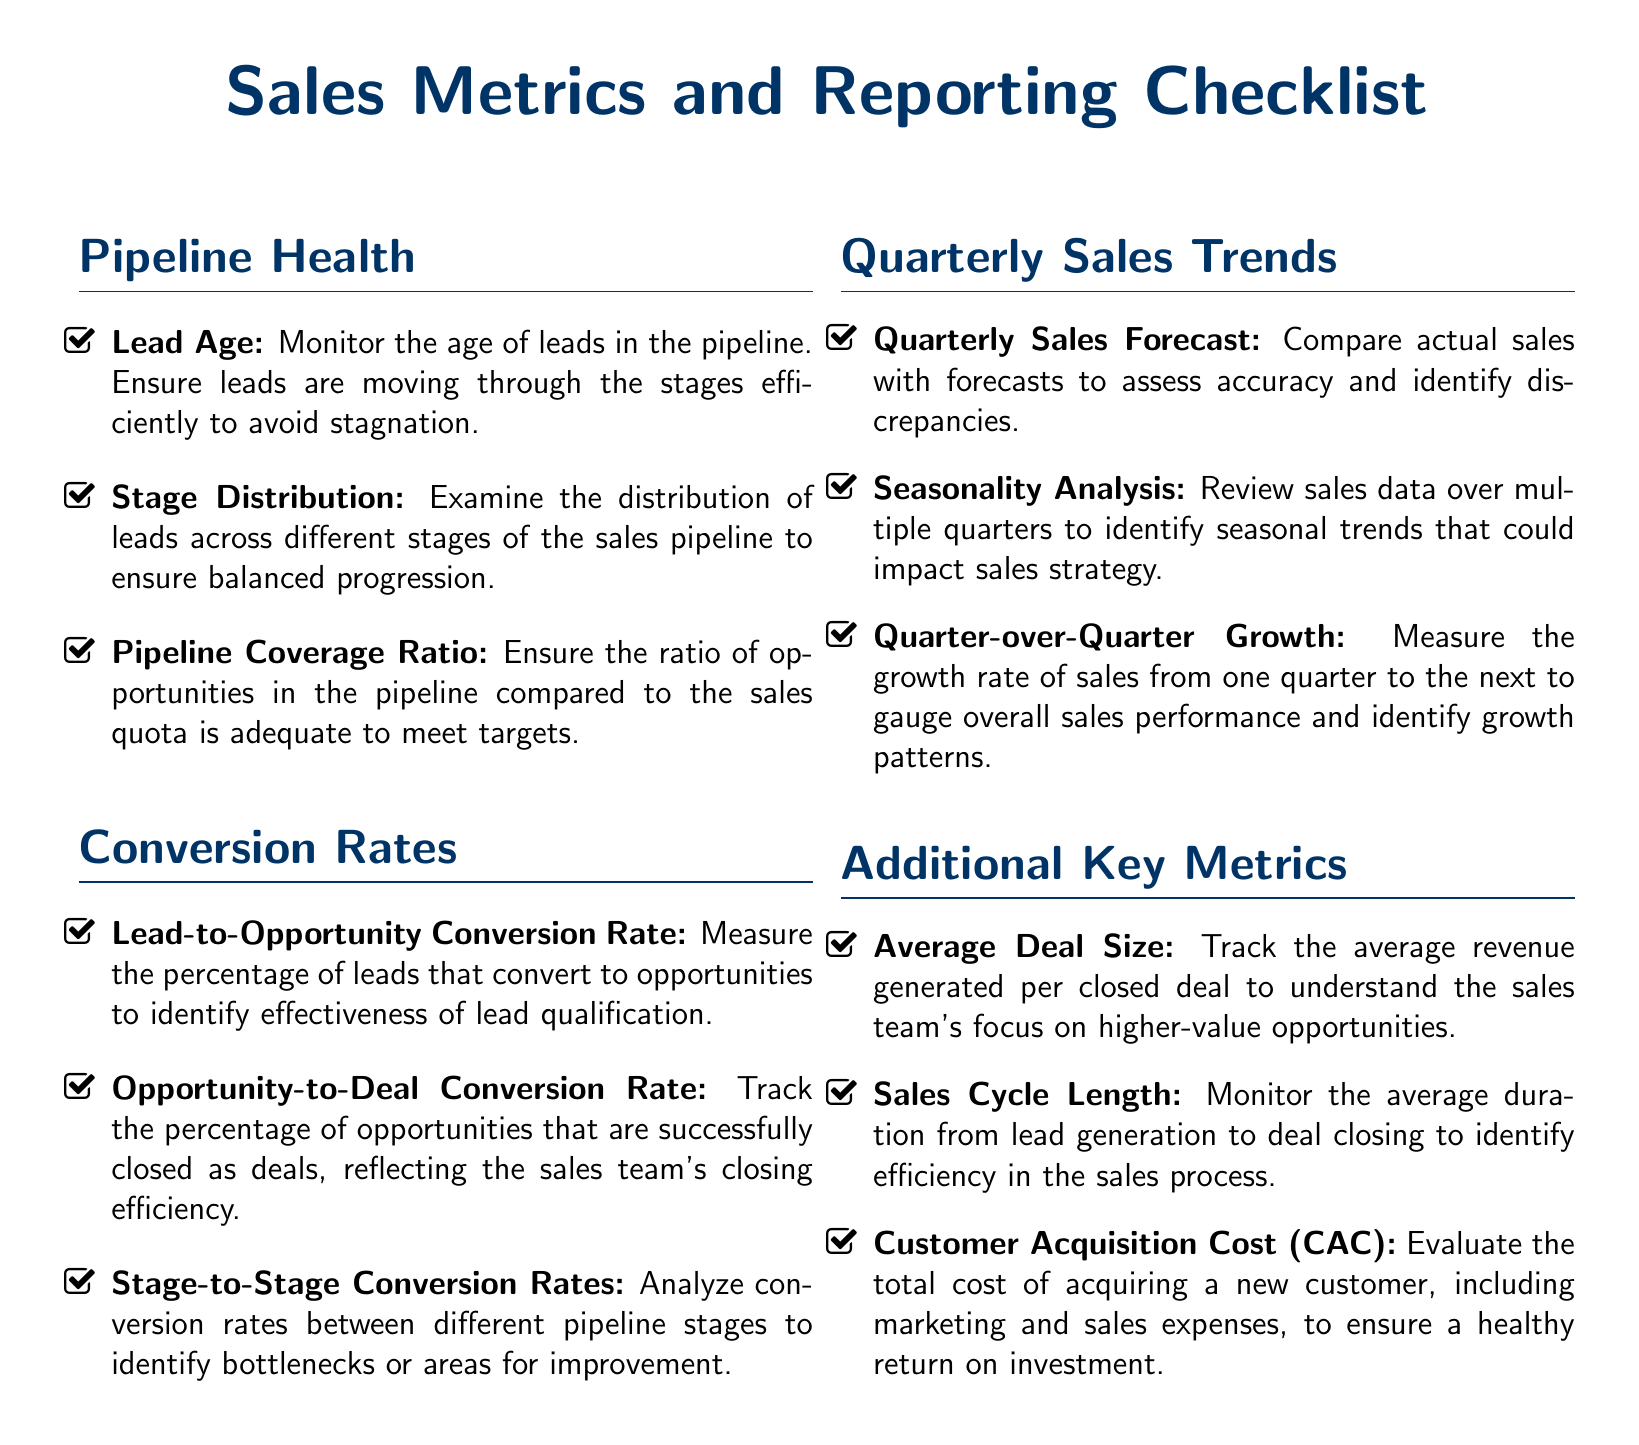What is monitored to ensure leads are moving efficiently? The document specifies that lead age should be monitored to ensure leads are moving through the stages efficiently.
Answer: Lead Age Which metric analyzes conversion rates between different pipeline stages? The document states that stage-to-stage conversion rates should be analyzed to identify bottlenecks or areas for improvement.
Answer: Stage-to-Stage Conversion Rates What should be compared to assess forecast accuracy? The document mentions comparing actual sales with forecasts to assess accuracy.
Answer: Quarterly Sales Forecast What metric evaluates the total cost of acquiring a new customer? The document states that customer acquisition cost (CAC) evaluates the total cost of acquiring a new customer.
Answer: Customer Acquisition Cost (CAC) How is the efficiency of the sales process monitored? The document indicates that the average duration from lead generation to deal closing is monitored to identify efficiency.
Answer: Sales Cycle Length What is the focus of tracking average deal size? The document specifies tracking average deal size to understand the focus on higher-value opportunities.
Answer: Higher-value opportunities 